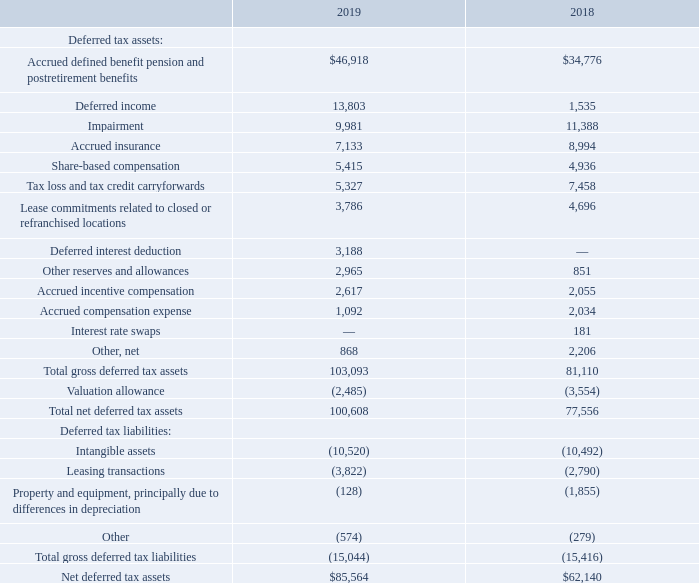The tax effects of temporary differences that give rise to significant portions of deferred tax assets and deferred tax liabilities at each fiscal year-end are presented below (in thousands):
The Tax Act was enacted into law on December 22, 2017. The Tax Act included a reduction in the U.S. federal statutory corporate income tax rate (the “Tax Rate”) from 35% to 21% and introduced new limitations on certain business deductions. As a result, for the fiscal year ended September 30, 2018, we recognized a year-to-date, non-cash $32.5 million tax provision expense impact primarily related to the re-measurement of our deferred tax assets and liabilities due to the reduced Tax Rate.
Deferred tax assets as of September 29, 2019 include state net operating loss carry-forwards of approximately$27.4 million expiring at various times between 2020 and 2038. At September 29, 2019, we recorded a valuation allowance of$2.5 million related to losses and state tax credits, which decreased from the$3.6 million at September 30, 2018 primarily due to the release of the valuation allowance on prior year net operating losses. We believe that it is more likely than not that these net operating loss and credit carry-forwards will not be realized and that all other deferred tax assets will be realized through future taxable income or alternative tax strategies.
The major jurisdictions in which the Company files income tax returns include the United States and states in which we operate that impose an income tax. The federal statutes of limitations have not expired for fiscal years 2016 and forward. The statutes of limitations for California and Texas, which constitute the Company’s major state tax jurisdictions, have not expired for fiscal years 2015 and forward.
When was the Tax Act enacted into law? December 22, 2017. Why was there a decrease of valuation allowance from 2018 to 2019? Due to the release of the valuation allowance on prior year net operating losses. What was the net deferred tax assets in 2019?
Answer scale should be: thousand. $85,564. What is the difference in net deferred tax assets between 2018 and 2019?
Answer scale should be: thousand. $85,564-$62,140
Answer: 23424. What is the average total gross deferred tax assets for 2018 and 2019?
Answer scale should be: thousand. (103,093+81,110)/2
Answer: 92101.5. What is the percentage change in accrued incentive compensation from 2018 to 2019?
Answer scale should be: percent. (2,617-2,055)/2,055
Answer: 27.35. 